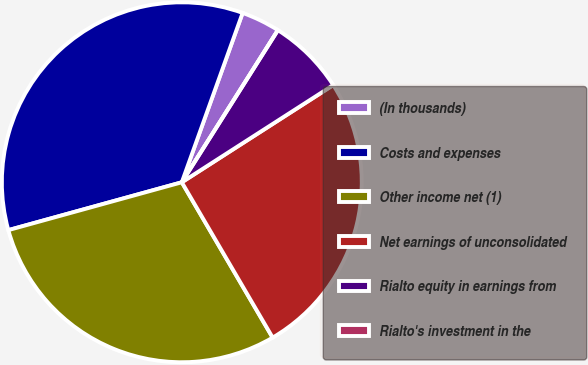<chart> <loc_0><loc_0><loc_500><loc_500><pie_chart><fcel>(In thousands)<fcel>Costs and expenses<fcel>Other income net (1)<fcel>Net earnings of unconsolidated<fcel>Rialto equity in earnings from<fcel>Rialto's investment in the<nl><fcel>3.48%<fcel>34.77%<fcel>29.14%<fcel>25.66%<fcel>6.95%<fcel>0.0%<nl></chart> 